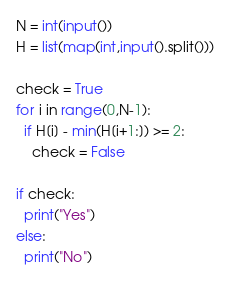Convert code to text. <code><loc_0><loc_0><loc_500><loc_500><_Python_>N = int(input())
H = list(map(int,input().split()))

check = True
for i in range(0,N-1):
  if H[i] - min(H[i+1:]) >= 2:
    check = False

if check:
  print("Yes")
else:
  print("No")</code> 